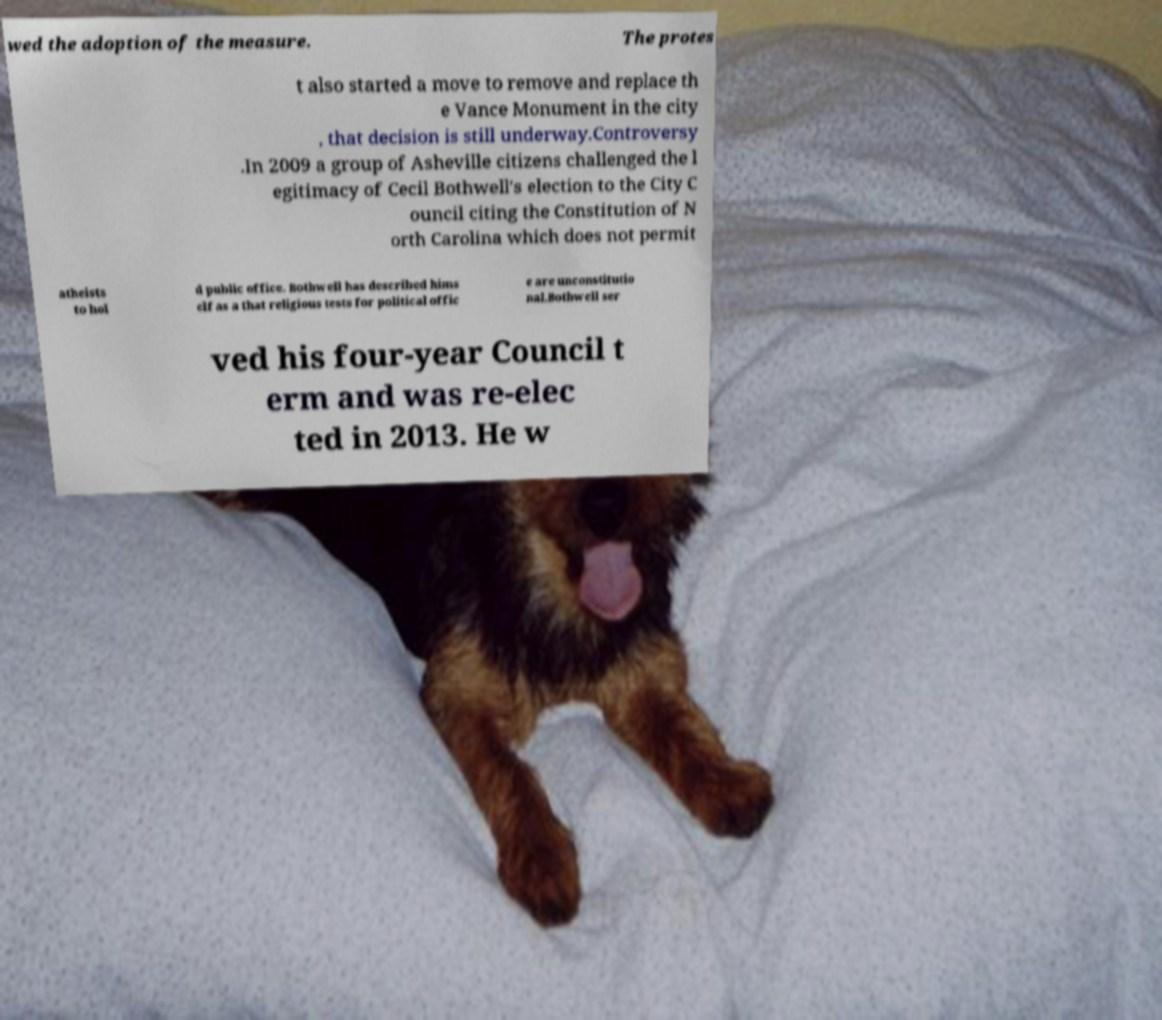For documentation purposes, I need the text within this image transcribed. Could you provide that? wed the adoption of the measure. The protes t also started a move to remove and replace th e Vance Monument in the city , that decision is still underway.Controversy .In 2009 a group of Asheville citizens challenged the l egitimacy of Cecil Bothwell's election to the City C ouncil citing the Constitution of N orth Carolina which does not permit atheists to hol d public office. Bothwell has described hims elf as a that religious tests for political offic e are unconstitutio nal.Bothwell ser ved his four-year Council t erm and was re-elec ted in 2013. He w 